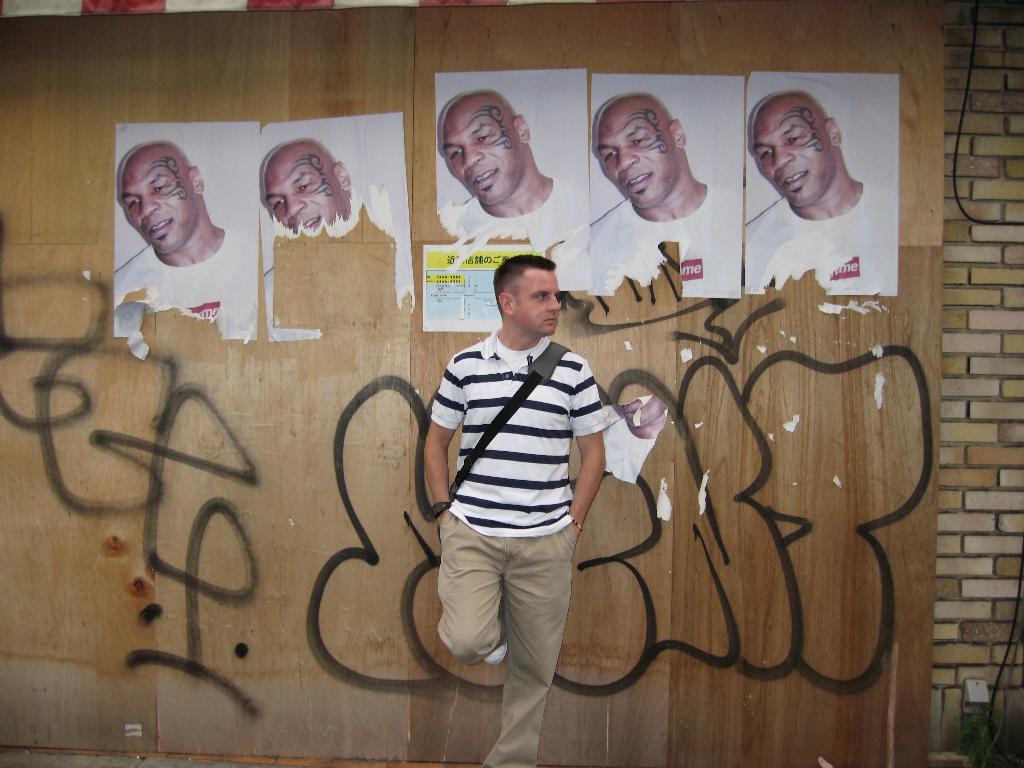Describe this image in one or two sentences. In this image there is a man standing near the wall by keeping one leg on the wall. To the wall there are photos of a man. At the bottom there is some drawing on the wall. 